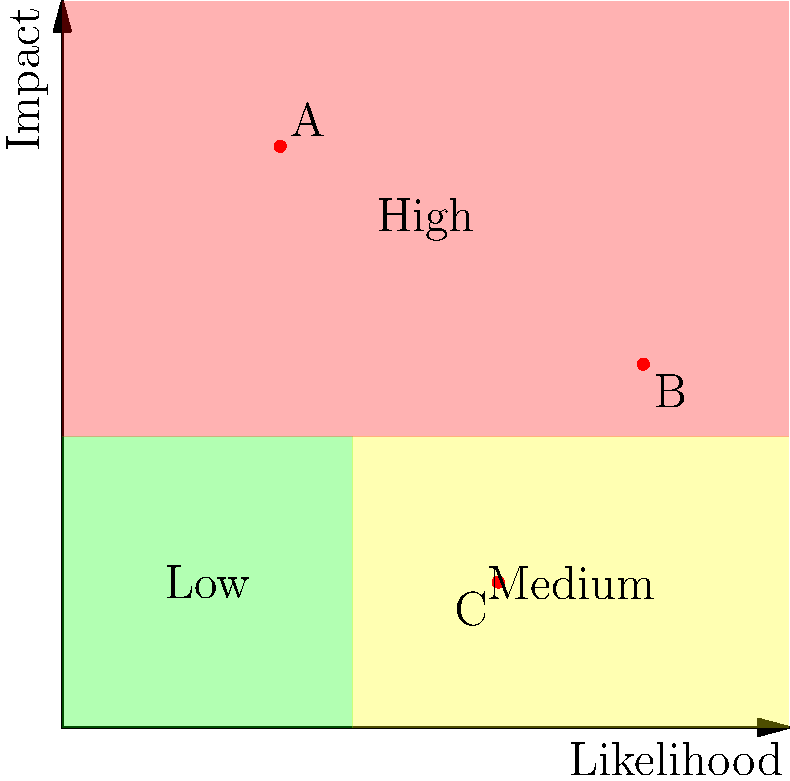Based on the risk matrix shown, which of the plotted events (A, B, or C) poses the highest risk to the power utility company's infrastructure in terms of potential impact from natural disasters? To determine which event poses the highest risk, we need to analyze the position of each event on the risk matrix:

1. Understand the risk matrix:
   - The x-axis represents the likelihood of an event occurring.
   - The y-axis represents the impact of the event.
   - The matrix is divided into three risk levels: Low (green), Medium (yellow), and High (red).

2. Analyze each event:
   - Event A: Located at approximately (1.5, 4) on the matrix.
     - Low likelihood but very high impact.
     - Falls in the high-risk (red) zone.
   
   - Event B: Located at approximately (4, 2.5) on the matrix.
     - High likelihood with medium-high impact.
     - Falls in the high-risk (red) zone.
   
   - Event C: Located at approximately (3, 1) on the matrix.
     - Medium-high likelihood but low impact.
     - Falls in the medium-risk (yellow) zone.

3. Compare the events:
   - Both A and B are in the high-risk zone, while C is in the medium-risk zone.
   - Between A and B, A has a higher position on the y-axis (impact).

4. Conclusion:
   Event A poses the highest risk due to its position highest on the impact scale, despite its lower likelihood. In the context of natural disasters and infrastructure, high-impact events can cause catastrophic damage even if they are less likely to occur.
Answer: Event A 